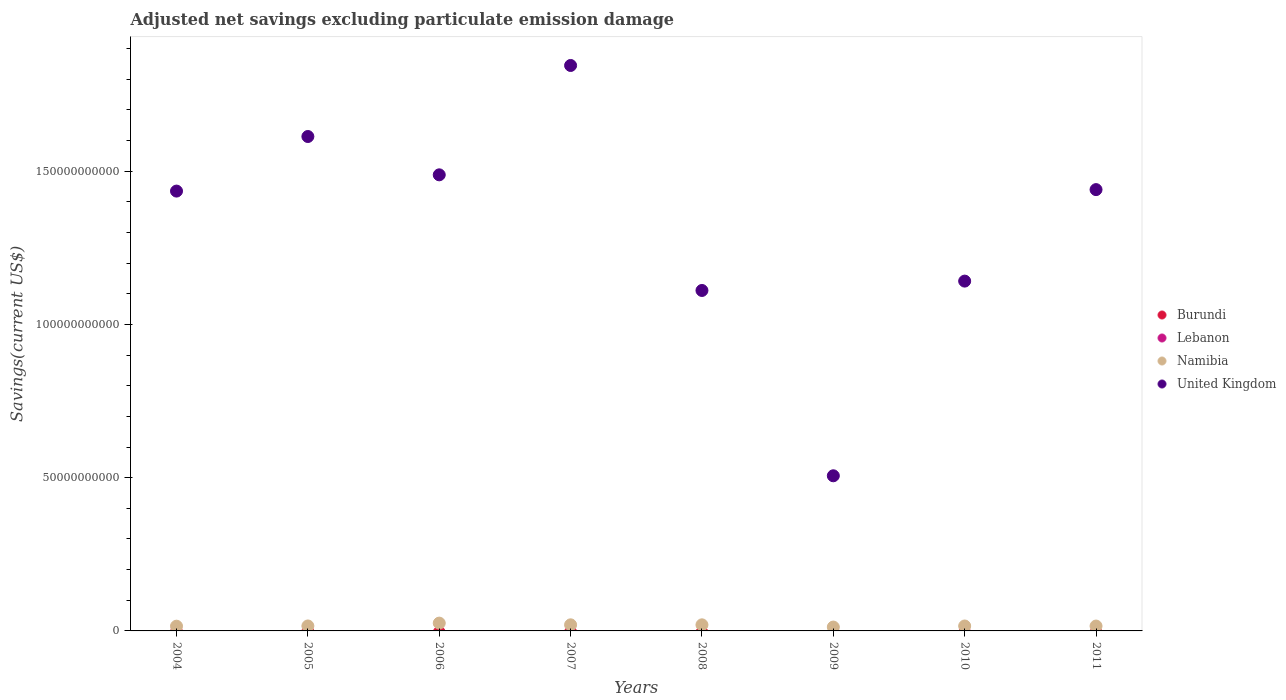Is the number of dotlines equal to the number of legend labels?
Ensure brevity in your answer.  No. Across all years, what is the maximum adjusted net savings in United Kingdom?
Keep it short and to the point. 1.85e+11. Across all years, what is the minimum adjusted net savings in Namibia?
Provide a short and direct response. 1.26e+09. What is the total adjusted net savings in Lebanon in the graph?
Keep it short and to the point. 0. What is the difference between the adjusted net savings in Namibia in 2009 and that in 2010?
Provide a short and direct response. -3.47e+08. What is the difference between the adjusted net savings in Namibia in 2004 and the adjusted net savings in Burundi in 2010?
Provide a succinct answer. 1.54e+09. What is the average adjusted net savings in Lebanon per year?
Offer a very short reply. 0. What is the ratio of the adjusted net savings in United Kingdom in 2006 to that in 2007?
Make the answer very short. 0.81. What is the difference between the highest and the second highest adjusted net savings in Namibia?
Provide a short and direct response. 5.59e+08. What is the difference between the highest and the lowest adjusted net savings in United Kingdom?
Make the answer very short. 1.34e+11. Is the sum of the adjusted net savings in Namibia in 2004 and 2011 greater than the maximum adjusted net savings in United Kingdom across all years?
Ensure brevity in your answer.  No. Is it the case that in every year, the sum of the adjusted net savings in Lebanon and adjusted net savings in Namibia  is greater than the sum of adjusted net savings in United Kingdom and adjusted net savings in Burundi?
Provide a succinct answer. No. Does the adjusted net savings in United Kingdom monotonically increase over the years?
Your answer should be compact. No. Is the adjusted net savings in Lebanon strictly less than the adjusted net savings in Namibia over the years?
Offer a very short reply. Yes. How many dotlines are there?
Your answer should be very brief. 2. What is the difference between two consecutive major ticks on the Y-axis?
Offer a terse response. 5.00e+1. Does the graph contain any zero values?
Ensure brevity in your answer.  Yes. Does the graph contain grids?
Your answer should be very brief. No. How many legend labels are there?
Offer a very short reply. 4. How are the legend labels stacked?
Make the answer very short. Vertical. What is the title of the graph?
Offer a terse response. Adjusted net savings excluding particulate emission damage. What is the label or title of the X-axis?
Offer a terse response. Years. What is the label or title of the Y-axis?
Keep it short and to the point. Savings(current US$). What is the Savings(current US$) in Lebanon in 2004?
Your response must be concise. 0. What is the Savings(current US$) of Namibia in 2004?
Keep it short and to the point. 1.54e+09. What is the Savings(current US$) of United Kingdom in 2004?
Your answer should be compact. 1.44e+11. What is the Savings(current US$) of Burundi in 2005?
Offer a very short reply. 0. What is the Savings(current US$) of Lebanon in 2005?
Offer a very short reply. 0. What is the Savings(current US$) in Namibia in 2005?
Your answer should be very brief. 1.62e+09. What is the Savings(current US$) of United Kingdom in 2005?
Provide a succinct answer. 1.61e+11. What is the Savings(current US$) of Burundi in 2006?
Your response must be concise. 0. What is the Savings(current US$) in Lebanon in 2006?
Provide a succinct answer. 0. What is the Savings(current US$) of Namibia in 2006?
Make the answer very short. 2.55e+09. What is the Savings(current US$) of United Kingdom in 2006?
Your answer should be compact. 1.49e+11. What is the Savings(current US$) in Lebanon in 2007?
Ensure brevity in your answer.  0. What is the Savings(current US$) of Namibia in 2007?
Offer a very short reply. 1.99e+09. What is the Savings(current US$) of United Kingdom in 2007?
Give a very brief answer. 1.85e+11. What is the Savings(current US$) of Burundi in 2008?
Your answer should be very brief. 0. What is the Savings(current US$) in Lebanon in 2008?
Provide a short and direct response. 0. What is the Savings(current US$) in Namibia in 2008?
Offer a terse response. 1.99e+09. What is the Savings(current US$) in United Kingdom in 2008?
Offer a terse response. 1.11e+11. What is the Savings(current US$) of Burundi in 2009?
Offer a terse response. 0. What is the Savings(current US$) of Lebanon in 2009?
Provide a short and direct response. 0. What is the Savings(current US$) of Namibia in 2009?
Your response must be concise. 1.26e+09. What is the Savings(current US$) of United Kingdom in 2009?
Your response must be concise. 5.06e+1. What is the Savings(current US$) of Burundi in 2010?
Provide a short and direct response. 0. What is the Savings(current US$) of Lebanon in 2010?
Make the answer very short. 0. What is the Savings(current US$) in Namibia in 2010?
Offer a very short reply. 1.61e+09. What is the Savings(current US$) of United Kingdom in 2010?
Make the answer very short. 1.14e+11. What is the Savings(current US$) of Namibia in 2011?
Offer a very short reply. 1.59e+09. What is the Savings(current US$) of United Kingdom in 2011?
Your response must be concise. 1.44e+11. Across all years, what is the maximum Savings(current US$) of Namibia?
Provide a short and direct response. 2.55e+09. Across all years, what is the maximum Savings(current US$) in United Kingdom?
Ensure brevity in your answer.  1.85e+11. Across all years, what is the minimum Savings(current US$) of Namibia?
Offer a terse response. 1.26e+09. Across all years, what is the minimum Savings(current US$) of United Kingdom?
Your answer should be very brief. 5.06e+1. What is the total Savings(current US$) of Lebanon in the graph?
Make the answer very short. 0. What is the total Savings(current US$) of Namibia in the graph?
Offer a very short reply. 1.41e+1. What is the total Savings(current US$) in United Kingdom in the graph?
Your answer should be compact. 1.06e+12. What is the difference between the Savings(current US$) in Namibia in 2004 and that in 2005?
Your answer should be compact. -7.61e+07. What is the difference between the Savings(current US$) in United Kingdom in 2004 and that in 2005?
Ensure brevity in your answer.  -1.78e+1. What is the difference between the Savings(current US$) of Namibia in 2004 and that in 2006?
Your response must be concise. -1.00e+09. What is the difference between the Savings(current US$) of United Kingdom in 2004 and that in 2006?
Give a very brief answer. -5.31e+09. What is the difference between the Savings(current US$) in Namibia in 2004 and that in 2007?
Offer a very short reply. -4.44e+08. What is the difference between the Savings(current US$) in United Kingdom in 2004 and that in 2007?
Ensure brevity in your answer.  -4.10e+1. What is the difference between the Savings(current US$) in Namibia in 2004 and that in 2008?
Offer a very short reply. -4.41e+08. What is the difference between the Savings(current US$) in United Kingdom in 2004 and that in 2008?
Give a very brief answer. 3.24e+1. What is the difference between the Savings(current US$) in Namibia in 2004 and that in 2009?
Your answer should be very brief. 2.85e+08. What is the difference between the Savings(current US$) of United Kingdom in 2004 and that in 2009?
Provide a succinct answer. 9.29e+1. What is the difference between the Savings(current US$) in Namibia in 2004 and that in 2010?
Ensure brevity in your answer.  -6.21e+07. What is the difference between the Savings(current US$) of United Kingdom in 2004 and that in 2010?
Your answer should be very brief. 2.94e+1. What is the difference between the Savings(current US$) in Namibia in 2004 and that in 2011?
Offer a terse response. -4.54e+07. What is the difference between the Savings(current US$) in United Kingdom in 2004 and that in 2011?
Your answer should be very brief. -4.80e+08. What is the difference between the Savings(current US$) of Namibia in 2005 and that in 2006?
Offer a terse response. -9.27e+08. What is the difference between the Savings(current US$) of United Kingdom in 2005 and that in 2006?
Your answer should be very brief. 1.25e+1. What is the difference between the Savings(current US$) in Namibia in 2005 and that in 2007?
Give a very brief answer. -3.68e+08. What is the difference between the Savings(current US$) in United Kingdom in 2005 and that in 2007?
Provide a short and direct response. -2.32e+1. What is the difference between the Savings(current US$) in Namibia in 2005 and that in 2008?
Keep it short and to the point. -3.65e+08. What is the difference between the Savings(current US$) of United Kingdom in 2005 and that in 2008?
Make the answer very short. 5.02e+1. What is the difference between the Savings(current US$) in Namibia in 2005 and that in 2009?
Ensure brevity in your answer.  3.61e+08. What is the difference between the Savings(current US$) in United Kingdom in 2005 and that in 2009?
Offer a very short reply. 1.11e+11. What is the difference between the Savings(current US$) in Namibia in 2005 and that in 2010?
Keep it short and to the point. 1.40e+07. What is the difference between the Savings(current US$) of United Kingdom in 2005 and that in 2010?
Ensure brevity in your answer.  4.72e+1. What is the difference between the Savings(current US$) in Namibia in 2005 and that in 2011?
Offer a terse response. 3.07e+07. What is the difference between the Savings(current US$) of United Kingdom in 2005 and that in 2011?
Ensure brevity in your answer.  1.73e+1. What is the difference between the Savings(current US$) in Namibia in 2006 and that in 2007?
Give a very brief answer. 5.59e+08. What is the difference between the Savings(current US$) of United Kingdom in 2006 and that in 2007?
Your answer should be very brief. -3.57e+1. What is the difference between the Savings(current US$) in Namibia in 2006 and that in 2008?
Your response must be concise. 5.61e+08. What is the difference between the Savings(current US$) of United Kingdom in 2006 and that in 2008?
Ensure brevity in your answer.  3.77e+1. What is the difference between the Savings(current US$) in Namibia in 2006 and that in 2009?
Give a very brief answer. 1.29e+09. What is the difference between the Savings(current US$) of United Kingdom in 2006 and that in 2009?
Offer a terse response. 9.82e+1. What is the difference between the Savings(current US$) of Namibia in 2006 and that in 2010?
Ensure brevity in your answer.  9.41e+08. What is the difference between the Savings(current US$) of United Kingdom in 2006 and that in 2010?
Keep it short and to the point. 3.47e+1. What is the difference between the Savings(current US$) in Namibia in 2006 and that in 2011?
Ensure brevity in your answer.  9.57e+08. What is the difference between the Savings(current US$) in United Kingdom in 2006 and that in 2011?
Make the answer very short. 4.83e+09. What is the difference between the Savings(current US$) of Namibia in 2007 and that in 2008?
Offer a terse response. 2.53e+06. What is the difference between the Savings(current US$) in United Kingdom in 2007 and that in 2008?
Make the answer very short. 7.34e+1. What is the difference between the Savings(current US$) of Namibia in 2007 and that in 2009?
Make the answer very short. 7.29e+08. What is the difference between the Savings(current US$) of United Kingdom in 2007 and that in 2009?
Your answer should be very brief. 1.34e+11. What is the difference between the Savings(current US$) of Namibia in 2007 and that in 2010?
Make the answer very short. 3.82e+08. What is the difference between the Savings(current US$) in United Kingdom in 2007 and that in 2010?
Your answer should be very brief. 7.04e+1. What is the difference between the Savings(current US$) of Namibia in 2007 and that in 2011?
Your answer should be compact. 3.98e+08. What is the difference between the Savings(current US$) of United Kingdom in 2007 and that in 2011?
Offer a terse response. 4.05e+1. What is the difference between the Savings(current US$) in Namibia in 2008 and that in 2009?
Make the answer very short. 7.27e+08. What is the difference between the Savings(current US$) of United Kingdom in 2008 and that in 2009?
Provide a succinct answer. 6.05e+1. What is the difference between the Savings(current US$) in Namibia in 2008 and that in 2010?
Offer a very short reply. 3.79e+08. What is the difference between the Savings(current US$) of United Kingdom in 2008 and that in 2010?
Provide a short and direct response. -3.06e+09. What is the difference between the Savings(current US$) in Namibia in 2008 and that in 2011?
Offer a very short reply. 3.96e+08. What is the difference between the Savings(current US$) in United Kingdom in 2008 and that in 2011?
Keep it short and to the point. -3.29e+1. What is the difference between the Savings(current US$) in Namibia in 2009 and that in 2010?
Your answer should be compact. -3.47e+08. What is the difference between the Savings(current US$) in United Kingdom in 2009 and that in 2010?
Your answer should be very brief. -6.35e+1. What is the difference between the Savings(current US$) of Namibia in 2009 and that in 2011?
Your answer should be very brief. -3.31e+08. What is the difference between the Savings(current US$) in United Kingdom in 2009 and that in 2011?
Provide a short and direct response. -9.34e+1. What is the difference between the Savings(current US$) of Namibia in 2010 and that in 2011?
Ensure brevity in your answer.  1.67e+07. What is the difference between the Savings(current US$) in United Kingdom in 2010 and that in 2011?
Keep it short and to the point. -2.99e+1. What is the difference between the Savings(current US$) in Namibia in 2004 and the Savings(current US$) in United Kingdom in 2005?
Offer a very short reply. -1.60e+11. What is the difference between the Savings(current US$) of Namibia in 2004 and the Savings(current US$) of United Kingdom in 2006?
Your response must be concise. -1.47e+11. What is the difference between the Savings(current US$) in Namibia in 2004 and the Savings(current US$) in United Kingdom in 2007?
Keep it short and to the point. -1.83e+11. What is the difference between the Savings(current US$) of Namibia in 2004 and the Savings(current US$) of United Kingdom in 2008?
Provide a short and direct response. -1.10e+11. What is the difference between the Savings(current US$) in Namibia in 2004 and the Savings(current US$) in United Kingdom in 2009?
Offer a very short reply. -4.91e+1. What is the difference between the Savings(current US$) in Namibia in 2004 and the Savings(current US$) in United Kingdom in 2010?
Give a very brief answer. -1.13e+11. What is the difference between the Savings(current US$) in Namibia in 2004 and the Savings(current US$) in United Kingdom in 2011?
Your response must be concise. -1.42e+11. What is the difference between the Savings(current US$) of Namibia in 2005 and the Savings(current US$) of United Kingdom in 2006?
Make the answer very short. -1.47e+11. What is the difference between the Savings(current US$) of Namibia in 2005 and the Savings(current US$) of United Kingdom in 2007?
Your answer should be compact. -1.83e+11. What is the difference between the Savings(current US$) in Namibia in 2005 and the Savings(current US$) in United Kingdom in 2008?
Offer a terse response. -1.09e+11. What is the difference between the Savings(current US$) in Namibia in 2005 and the Savings(current US$) in United Kingdom in 2009?
Offer a terse response. -4.90e+1. What is the difference between the Savings(current US$) in Namibia in 2005 and the Savings(current US$) in United Kingdom in 2010?
Offer a very short reply. -1.13e+11. What is the difference between the Savings(current US$) in Namibia in 2005 and the Savings(current US$) in United Kingdom in 2011?
Offer a very short reply. -1.42e+11. What is the difference between the Savings(current US$) of Namibia in 2006 and the Savings(current US$) of United Kingdom in 2007?
Keep it short and to the point. -1.82e+11. What is the difference between the Savings(current US$) in Namibia in 2006 and the Savings(current US$) in United Kingdom in 2008?
Your answer should be compact. -1.09e+11. What is the difference between the Savings(current US$) of Namibia in 2006 and the Savings(current US$) of United Kingdom in 2009?
Your answer should be very brief. -4.81e+1. What is the difference between the Savings(current US$) in Namibia in 2006 and the Savings(current US$) in United Kingdom in 2010?
Your answer should be very brief. -1.12e+11. What is the difference between the Savings(current US$) in Namibia in 2006 and the Savings(current US$) in United Kingdom in 2011?
Give a very brief answer. -1.41e+11. What is the difference between the Savings(current US$) in Namibia in 2007 and the Savings(current US$) in United Kingdom in 2008?
Offer a very short reply. -1.09e+11. What is the difference between the Savings(current US$) of Namibia in 2007 and the Savings(current US$) of United Kingdom in 2009?
Keep it short and to the point. -4.86e+1. What is the difference between the Savings(current US$) in Namibia in 2007 and the Savings(current US$) in United Kingdom in 2010?
Provide a short and direct response. -1.12e+11. What is the difference between the Savings(current US$) of Namibia in 2007 and the Savings(current US$) of United Kingdom in 2011?
Ensure brevity in your answer.  -1.42e+11. What is the difference between the Savings(current US$) of Namibia in 2008 and the Savings(current US$) of United Kingdom in 2009?
Your answer should be compact. -4.86e+1. What is the difference between the Savings(current US$) in Namibia in 2008 and the Savings(current US$) in United Kingdom in 2010?
Keep it short and to the point. -1.12e+11. What is the difference between the Savings(current US$) of Namibia in 2008 and the Savings(current US$) of United Kingdom in 2011?
Provide a short and direct response. -1.42e+11. What is the difference between the Savings(current US$) in Namibia in 2009 and the Savings(current US$) in United Kingdom in 2010?
Your answer should be very brief. -1.13e+11. What is the difference between the Savings(current US$) of Namibia in 2009 and the Savings(current US$) of United Kingdom in 2011?
Make the answer very short. -1.43e+11. What is the difference between the Savings(current US$) of Namibia in 2010 and the Savings(current US$) of United Kingdom in 2011?
Your response must be concise. -1.42e+11. What is the average Savings(current US$) of Burundi per year?
Offer a terse response. 0. What is the average Savings(current US$) in Namibia per year?
Give a very brief answer. 1.77e+09. What is the average Savings(current US$) in United Kingdom per year?
Your response must be concise. 1.32e+11. In the year 2004, what is the difference between the Savings(current US$) of Namibia and Savings(current US$) of United Kingdom?
Ensure brevity in your answer.  -1.42e+11. In the year 2005, what is the difference between the Savings(current US$) of Namibia and Savings(current US$) of United Kingdom?
Your answer should be compact. -1.60e+11. In the year 2006, what is the difference between the Savings(current US$) of Namibia and Savings(current US$) of United Kingdom?
Keep it short and to the point. -1.46e+11. In the year 2007, what is the difference between the Savings(current US$) of Namibia and Savings(current US$) of United Kingdom?
Make the answer very short. -1.83e+11. In the year 2008, what is the difference between the Savings(current US$) in Namibia and Savings(current US$) in United Kingdom?
Give a very brief answer. -1.09e+11. In the year 2009, what is the difference between the Savings(current US$) in Namibia and Savings(current US$) in United Kingdom?
Offer a terse response. -4.94e+1. In the year 2010, what is the difference between the Savings(current US$) in Namibia and Savings(current US$) in United Kingdom?
Your response must be concise. -1.13e+11. In the year 2011, what is the difference between the Savings(current US$) in Namibia and Savings(current US$) in United Kingdom?
Your response must be concise. -1.42e+11. What is the ratio of the Savings(current US$) in Namibia in 2004 to that in 2005?
Offer a terse response. 0.95. What is the ratio of the Savings(current US$) of United Kingdom in 2004 to that in 2005?
Ensure brevity in your answer.  0.89. What is the ratio of the Savings(current US$) in Namibia in 2004 to that in 2006?
Make the answer very short. 0.61. What is the ratio of the Savings(current US$) in United Kingdom in 2004 to that in 2006?
Provide a short and direct response. 0.96. What is the ratio of the Savings(current US$) in Namibia in 2004 to that in 2007?
Your answer should be very brief. 0.78. What is the ratio of the Savings(current US$) in United Kingdom in 2004 to that in 2007?
Provide a short and direct response. 0.78. What is the ratio of the Savings(current US$) in United Kingdom in 2004 to that in 2008?
Provide a short and direct response. 1.29. What is the ratio of the Savings(current US$) of Namibia in 2004 to that in 2009?
Offer a terse response. 1.23. What is the ratio of the Savings(current US$) in United Kingdom in 2004 to that in 2009?
Your answer should be very brief. 2.84. What is the ratio of the Savings(current US$) in Namibia in 2004 to that in 2010?
Offer a very short reply. 0.96. What is the ratio of the Savings(current US$) of United Kingdom in 2004 to that in 2010?
Offer a very short reply. 1.26. What is the ratio of the Savings(current US$) in Namibia in 2004 to that in 2011?
Give a very brief answer. 0.97. What is the ratio of the Savings(current US$) in Namibia in 2005 to that in 2006?
Provide a succinct answer. 0.64. What is the ratio of the Savings(current US$) of United Kingdom in 2005 to that in 2006?
Offer a very short reply. 1.08. What is the ratio of the Savings(current US$) in Namibia in 2005 to that in 2007?
Provide a succinct answer. 0.82. What is the ratio of the Savings(current US$) in United Kingdom in 2005 to that in 2007?
Your response must be concise. 0.87. What is the ratio of the Savings(current US$) in Namibia in 2005 to that in 2008?
Your response must be concise. 0.82. What is the ratio of the Savings(current US$) in United Kingdom in 2005 to that in 2008?
Ensure brevity in your answer.  1.45. What is the ratio of the Savings(current US$) in Namibia in 2005 to that in 2009?
Your answer should be compact. 1.29. What is the ratio of the Savings(current US$) of United Kingdom in 2005 to that in 2009?
Ensure brevity in your answer.  3.19. What is the ratio of the Savings(current US$) of Namibia in 2005 to that in 2010?
Give a very brief answer. 1.01. What is the ratio of the Savings(current US$) in United Kingdom in 2005 to that in 2010?
Make the answer very short. 1.41. What is the ratio of the Savings(current US$) of Namibia in 2005 to that in 2011?
Ensure brevity in your answer.  1.02. What is the ratio of the Savings(current US$) in United Kingdom in 2005 to that in 2011?
Your answer should be compact. 1.12. What is the ratio of the Savings(current US$) in Namibia in 2006 to that in 2007?
Provide a succinct answer. 1.28. What is the ratio of the Savings(current US$) in United Kingdom in 2006 to that in 2007?
Give a very brief answer. 0.81. What is the ratio of the Savings(current US$) of Namibia in 2006 to that in 2008?
Your answer should be compact. 1.28. What is the ratio of the Savings(current US$) in United Kingdom in 2006 to that in 2008?
Your answer should be compact. 1.34. What is the ratio of the Savings(current US$) in Namibia in 2006 to that in 2009?
Your answer should be very brief. 2.02. What is the ratio of the Savings(current US$) of United Kingdom in 2006 to that in 2009?
Give a very brief answer. 2.94. What is the ratio of the Savings(current US$) in Namibia in 2006 to that in 2010?
Ensure brevity in your answer.  1.59. What is the ratio of the Savings(current US$) of United Kingdom in 2006 to that in 2010?
Give a very brief answer. 1.3. What is the ratio of the Savings(current US$) in Namibia in 2006 to that in 2011?
Provide a succinct answer. 1.6. What is the ratio of the Savings(current US$) of United Kingdom in 2006 to that in 2011?
Give a very brief answer. 1.03. What is the ratio of the Savings(current US$) of United Kingdom in 2007 to that in 2008?
Your response must be concise. 1.66. What is the ratio of the Savings(current US$) in Namibia in 2007 to that in 2009?
Ensure brevity in your answer.  1.58. What is the ratio of the Savings(current US$) in United Kingdom in 2007 to that in 2009?
Keep it short and to the point. 3.64. What is the ratio of the Savings(current US$) in Namibia in 2007 to that in 2010?
Provide a succinct answer. 1.24. What is the ratio of the Savings(current US$) of United Kingdom in 2007 to that in 2010?
Ensure brevity in your answer.  1.62. What is the ratio of the Savings(current US$) in Namibia in 2007 to that in 2011?
Keep it short and to the point. 1.25. What is the ratio of the Savings(current US$) of United Kingdom in 2007 to that in 2011?
Offer a terse response. 1.28. What is the ratio of the Savings(current US$) in Namibia in 2008 to that in 2009?
Give a very brief answer. 1.58. What is the ratio of the Savings(current US$) in United Kingdom in 2008 to that in 2009?
Ensure brevity in your answer.  2.19. What is the ratio of the Savings(current US$) in Namibia in 2008 to that in 2010?
Make the answer very short. 1.24. What is the ratio of the Savings(current US$) in United Kingdom in 2008 to that in 2010?
Provide a short and direct response. 0.97. What is the ratio of the Savings(current US$) in Namibia in 2008 to that in 2011?
Give a very brief answer. 1.25. What is the ratio of the Savings(current US$) of United Kingdom in 2008 to that in 2011?
Your answer should be compact. 0.77. What is the ratio of the Savings(current US$) in Namibia in 2009 to that in 2010?
Ensure brevity in your answer.  0.78. What is the ratio of the Savings(current US$) in United Kingdom in 2009 to that in 2010?
Provide a short and direct response. 0.44. What is the ratio of the Savings(current US$) in Namibia in 2009 to that in 2011?
Your answer should be very brief. 0.79. What is the ratio of the Savings(current US$) of United Kingdom in 2009 to that in 2011?
Offer a very short reply. 0.35. What is the ratio of the Savings(current US$) in Namibia in 2010 to that in 2011?
Offer a terse response. 1.01. What is the ratio of the Savings(current US$) in United Kingdom in 2010 to that in 2011?
Give a very brief answer. 0.79. What is the difference between the highest and the second highest Savings(current US$) in Namibia?
Offer a terse response. 5.59e+08. What is the difference between the highest and the second highest Savings(current US$) in United Kingdom?
Your response must be concise. 2.32e+1. What is the difference between the highest and the lowest Savings(current US$) in Namibia?
Keep it short and to the point. 1.29e+09. What is the difference between the highest and the lowest Savings(current US$) of United Kingdom?
Make the answer very short. 1.34e+11. 